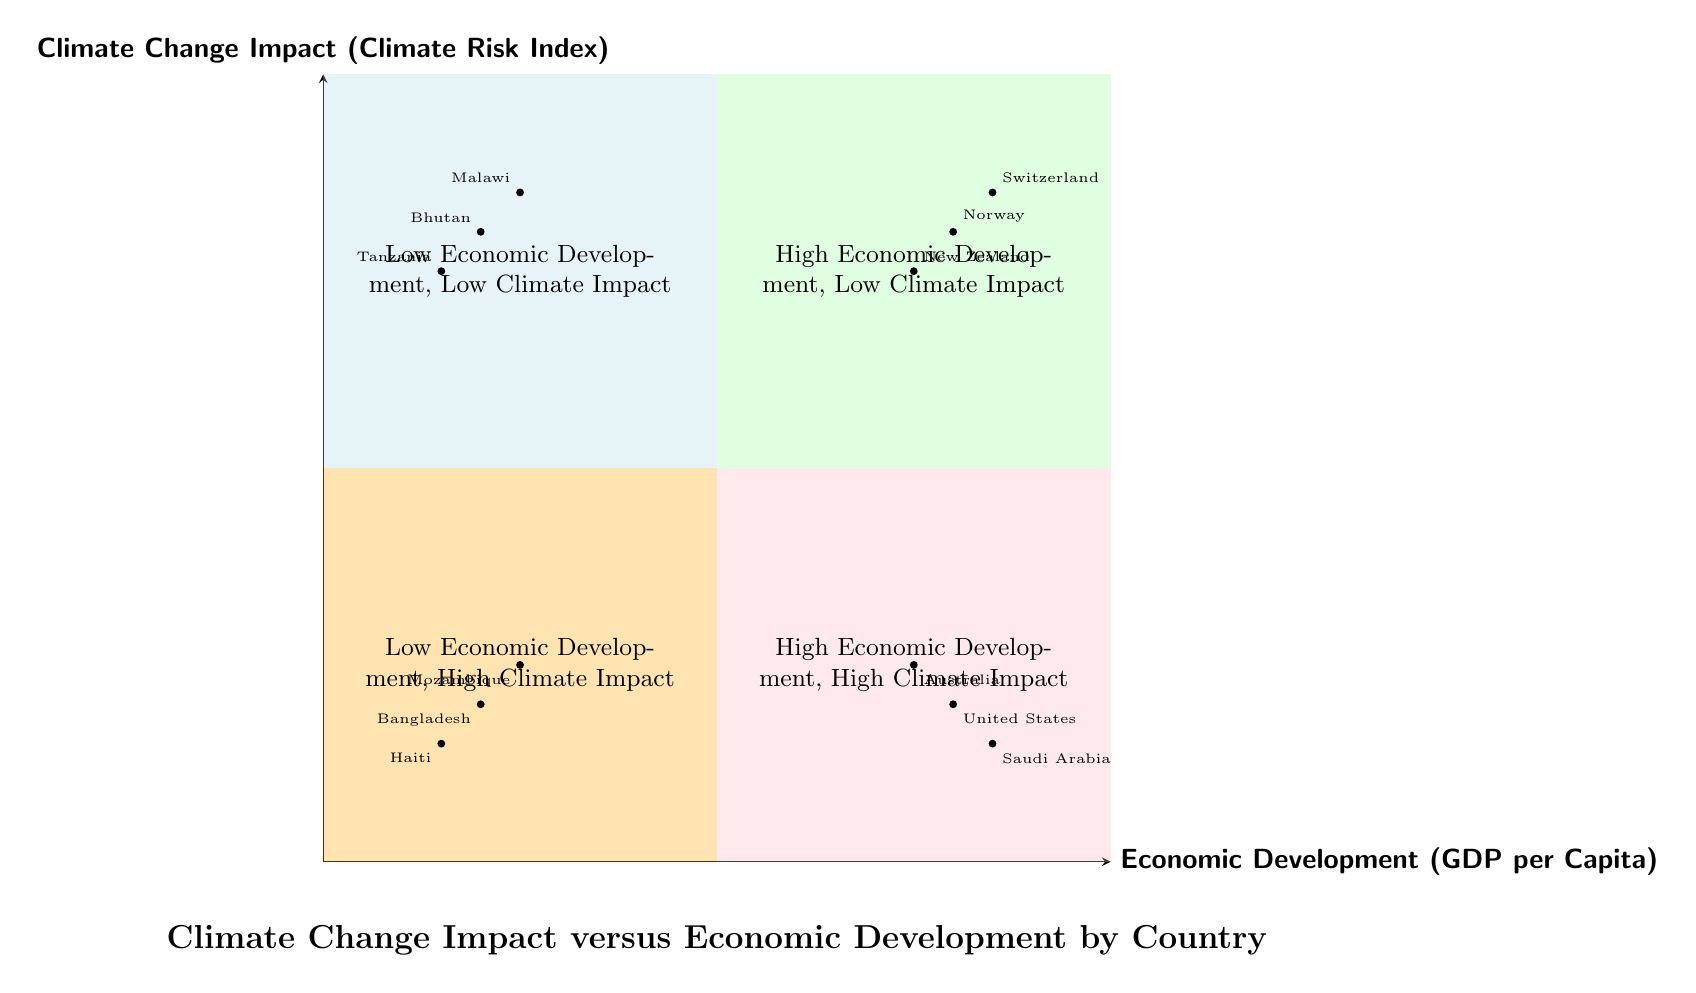What countries fall into the "High Economic Development, Low Climate Impact" quadrant? According to the diagram, this quadrant includes Norway, Switzerland, and New Zealand, as they exhibit both high levels of economic development and low climate impact.
Answer: Norway, Switzerland, New Zealand How many countries are in the "Low Economic Development, High Climate Impact" quadrant? The diagram shows three countries in this quadrant—Bangladesh, Haiti, and Mozambique—categorizing them by their low economic development and high climate impact.
Answer: 3 Which quadrant contains the United States? The United States is located in the "High Economic Development, High Climate Impact" quadrant, indicating that it has a high level of economic development but also faces significant climate impact challenges.
Answer: High Economic Development, High Climate Impact What is the relationship between economic development and climate impact for Bhutan? Bhutan is in the "Low Economic Development, Low Climate Impact" quadrant, indicating that although it has low economic development, it also experiences minimal climate impact.
Answer: Low Economic Development, Low Climate Impact Are there countries with low economic development that have low climate impact? Yes, Bhutan, Tanzania, and Malawi are examples of countries positioned in the "Low Economic Development, Low Climate Impact" quadrant, demonstrating that low economic development does not always correlate with high climate risks.
Answer: Yes 